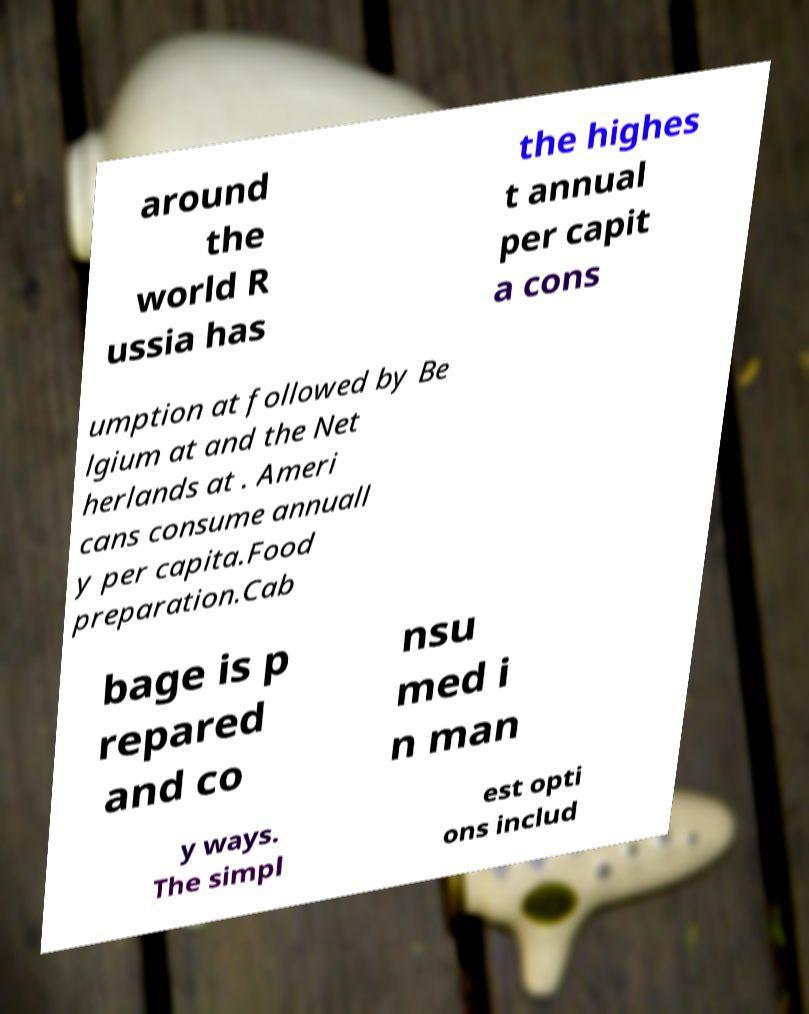Can you read and provide the text displayed in the image?This photo seems to have some interesting text. Can you extract and type it out for me? around the world R ussia has the highes t annual per capit a cons umption at followed by Be lgium at and the Net herlands at . Ameri cans consume annuall y per capita.Food preparation.Cab bage is p repared and co nsu med i n man y ways. The simpl est opti ons includ 